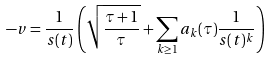<formula> <loc_0><loc_0><loc_500><loc_500>- v = \frac { 1 } { s ( t ) } \left ( \sqrt { \frac { \tau + 1 } { \tau } } + \sum _ { k \geq 1 } a _ { k } ( \tau ) \frac { 1 } { s ( t ) ^ { k } } \right )</formula> 